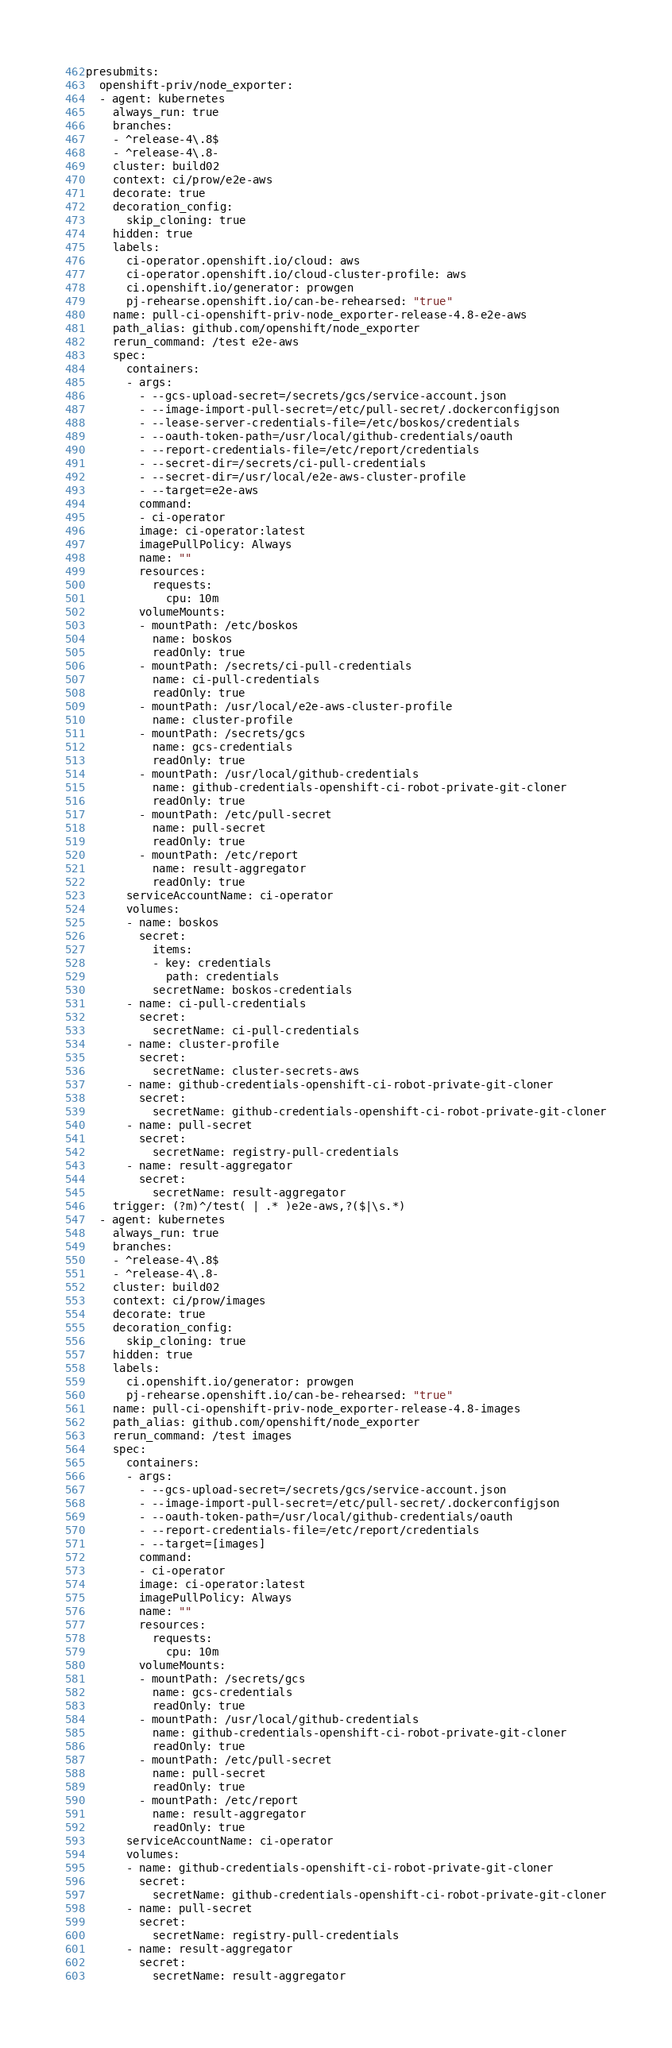<code> <loc_0><loc_0><loc_500><loc_500><_YAML_>presubmits:
  openshift-priv/node_exporter:
  - agent: kubernetes
    always_run: true
    branches:
    - ^release-4\.8$
    - ^release-4\.8-
    cluster: build02
    context: ci/prow/e2e-aws
    decorate: true
    decoration_config:
      skip_cloning: true
    hidden: true
    labels:
      ci-operator.openshift.io/cloud: aws
      ci-operator.openshift.io/cloud-cluster-profile: aws
      ci.openshift.io/generator: prowgen
      pj-rehearse.openshift.io/can-be-rehearsed: "true"
    name: pull-ci-openshift-priv-node_exporter-release-4.8-e2e-aws
    path_alias: github.com/openshift/node_exporter
    rerun_command: /test e2e-aws
    spec:
      containers:
      - args:
        - --gcs-upload-secret=/secrets/gcs/service-account.json
        - --image-import-pull-secret=/etc/pull-secret/.dockerconfigjson
        - --lease-server-credentials-file=/etc/boskos/credentials
        - --oauth-token-path=/usr/local/github-credentials/oauth
        - --report-credentials-file=/etc/report/credentials
        - --secret-dir=/secrets/ci-pull-credentials
        - --secret-dir=/usr/local/e2e-aws-cluster-profile
        - --target=e2e-aws
        command:
        - ci-operator
        image: ci-operator:latest
        imagePullPolicy: Always
        name: ""
        resources:
          requests:
            cpu: 10m
        volumeMounts:
        - mountPath: /etc/boskos
          name: boskos
          readOnly: true
        - mountPath: /secrets/ci-pull-credentials
          name: ci-pull-credentials
          readOnly: true
        - mountPath: /usr/local/e2e-aws-cluster-profile
          name: cluster-profile
        - mountPath: /secrets/gcs
          name: gcs-credentials
          readOnly: true
        - mountPath: /usr/local/github-credentials
          name: github-credentials-openshift-ci-robot-private-git-cloner
          readOnly: true
        - mountPath: /etc/pull-secret
          name: pull-secret
          readOnly: true
        - mountPath: /etc/report
          name: result-aggregator
          readOnly: true
      serviceAccountName: ci-operator
      volumes:
      - name: boskos
        secret:
          items:
          - key: credentials
            path: credentials
          secretName: boskos-credentials
      - name: ci-pull-credentials
        secret:
          secretName: ci-pull-credentials
      - name: cluster-profile
        secret:
          secretName: cluster-secrets-aws
      - name: github-credentials-openshift-ci-robot-private-git-cloner
        secret:
          secretName: github-credentials-openshift-ci-robot-private-git-cloner
      - name: pull-secret
        secret:
          secretName: registry-pull-credentials
      - name: result-aggregator
        secret:
          secretName: result-aggregator
    trigger: (?m)^/test( | .* )e2e-aws,?($|\s.*)
  - agent: kubernetes
    always_run: true
    branches:
    - ^release-4\.8$
    - ^release-4\.8-
    cluster: build02
    context: ci/prow/images
    decorate: true
    decoration_config:
      skip_cloning: true
    hidden: true
    labels:
      ci.openshift.io/generator: prowgen
      pj-rehearse.openshift.io/can-be-rehearsed: "true"
    name: pull-ci-openshift-priv-node_exporter-release-4.8-images
    path_alias: github.com/openshift/node_exporter
    rerun_command: /test images
    spec:
      containers:
      - args:
        - --gcs-upload-secret=/secrets/gcs/service-account.json
        - --image-import-pull-secret=/etc/pull-secret/.dockerconfigjson
        - --oauth-token-path=/usr/local/github-credentials/oauth
        - --report-credentials-file=/etc/report/credentials
        - --target=[images]
        command:
        - ci-operator
        image: ci-operator:latest
        imagePullPolicy: Always
        name: ""
        resources:
          requests:
            cpu: 10m
        volumeMounts:
        - mountPath: /secrets/gcs
          name: gcs-credentials
          readOnly: true
        - mountPath: /usr/local/github-credentials
          name: github-credentials-openshift-ci-robot-private-git-cloner
          readOnly: true
        - mountPath: /etc/pull-secret
          name: pull-secret
          readOnly: true
        - mountPath: /etc/report
          name: result-aggregator
          readOnly: true
      serviceAccountName: ci-operator
      volumes:
      - name: github-credentials-openshift-ci-robot-private-git-cloner
        secret:
          secretName: github-credentials-openshift-ci-robot-private-git-cloner
      - name: pull-secret
        secret:
          secretName: registry-pull-credentials
      - name: result-aggregator
        secret:
          secretName: result-aggregator</code> 